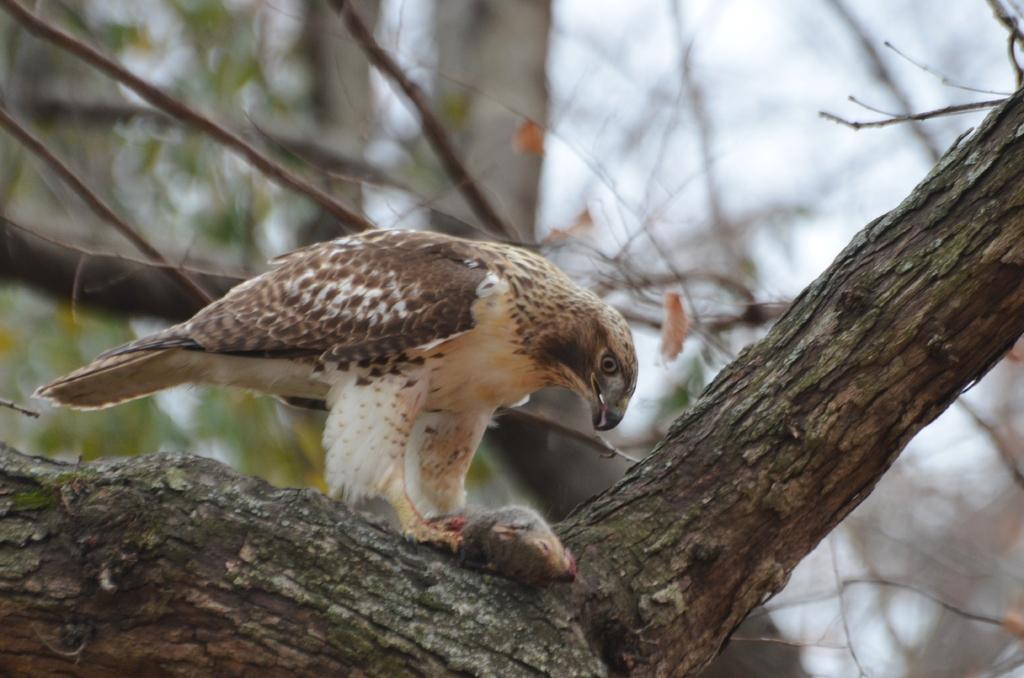Can you describe this image briefly? In this image I can see a bird on the tree. In the background, I can see the leaves. 